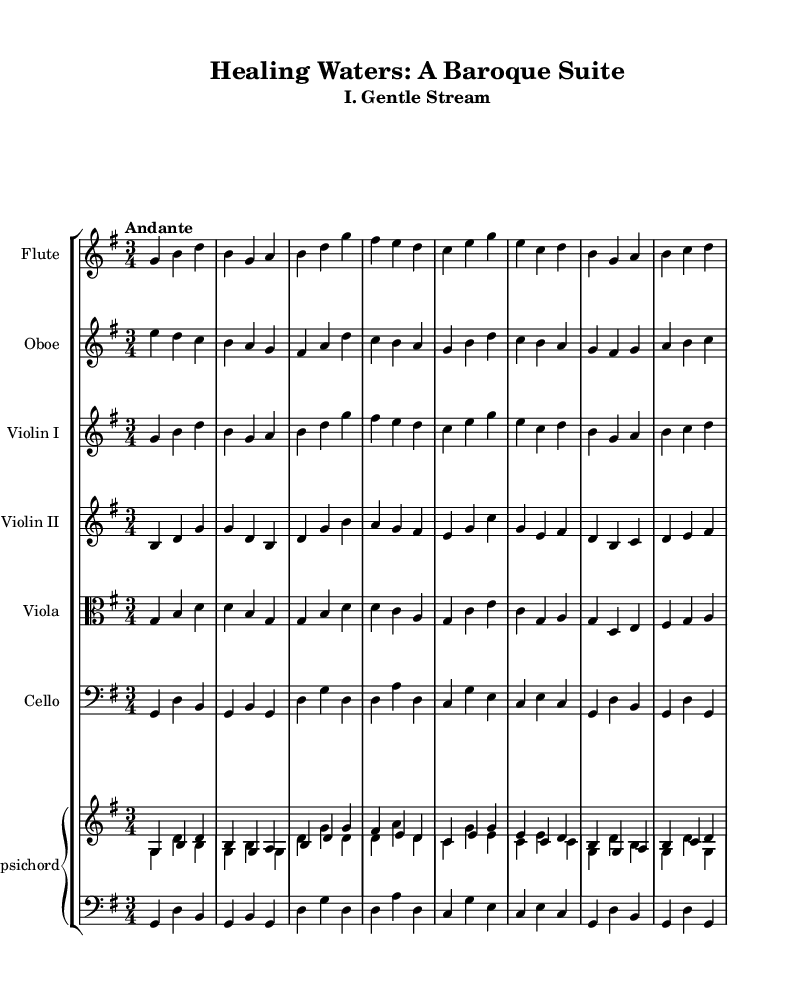What is the key signature of this music? The key signature is indicated by the number of sharps or flats at the beginning of the staff. In this case, there is only one sharp (F#), which means the key is G major.
Answer: G major What is the time signature of this music? The time signature is shown as a fraction at the beginning of the staff. Here, it is 3/4, indicating there are three beats in each measure and a quarter note receives one beat.
Answer: 3/4 What is the tempo marking for this piece? The tempo is usually noted above the staff. It indicates how fast or slow the music should be played. In this score, it is marked as "Andante", which suggests a moderate pace.
Answer: Andante How many instruments are in this suite? To determine the number of instruments, we can count the individual staves in the score. There are six different staves for instruments, plus a piano staff that combines two parts, giving us a total of seven instruments.
Answer: Seven Which instrument has the lowest range in this score? The instrument range is shown by the clef and the notes written. The cello plays in the bass clef and generally has a lower range than the other instruments, confirming it as the lowest.
Answer: Cello What harmonic roles do the flute and oboe play together in this suite? The flute and oboe often play melodies that complement each other; in this score, they provide a mix of harmonic support and melodic lines in the arrangements. Observing their respective parts, it’s seen they reinforce each other, typical of Baroque style.
Answer: Melodic lines What is the style of this music? This music is characterized by features typical of Baroque compositions, which include contrasts of texture, ornamentation, and a focus on harmony. The orchestral suite is inspired by nature, evident in the flowing melodic lines mimicking natural forms like streams.
Answer: Baroque 